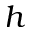<formula> <loc_0><loc_0><loc_500><loc_500>h</formula> 